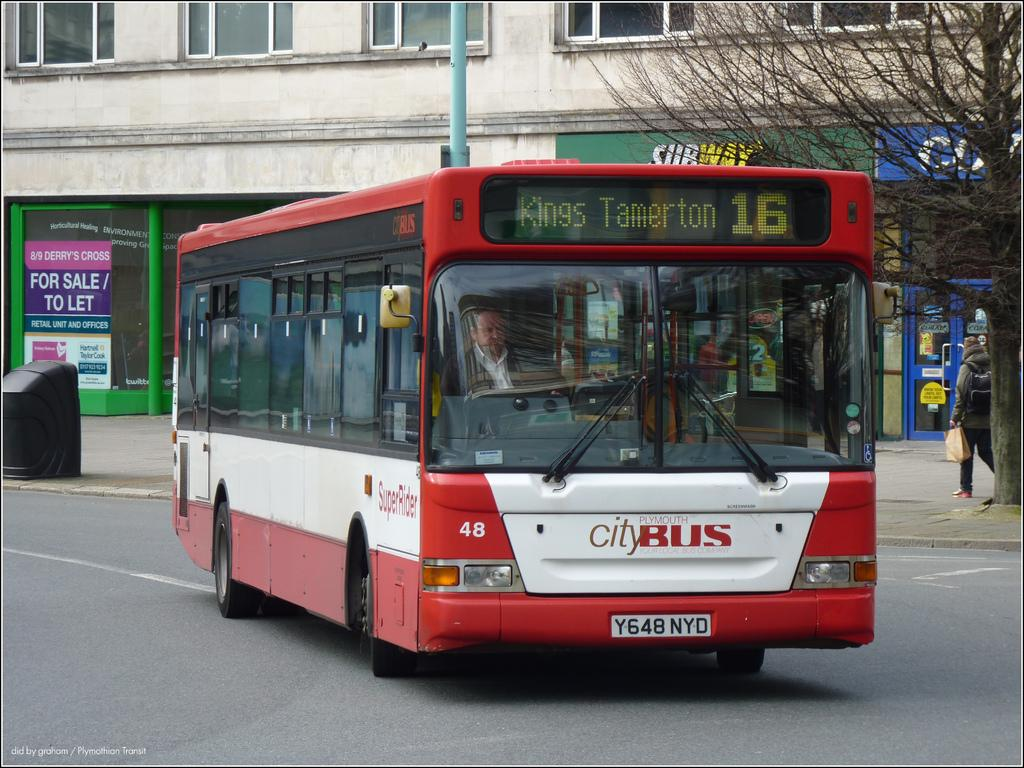<image>
Share a concise interpretation of the image provided. A single decker bus with the words City Bus on the bottom. 